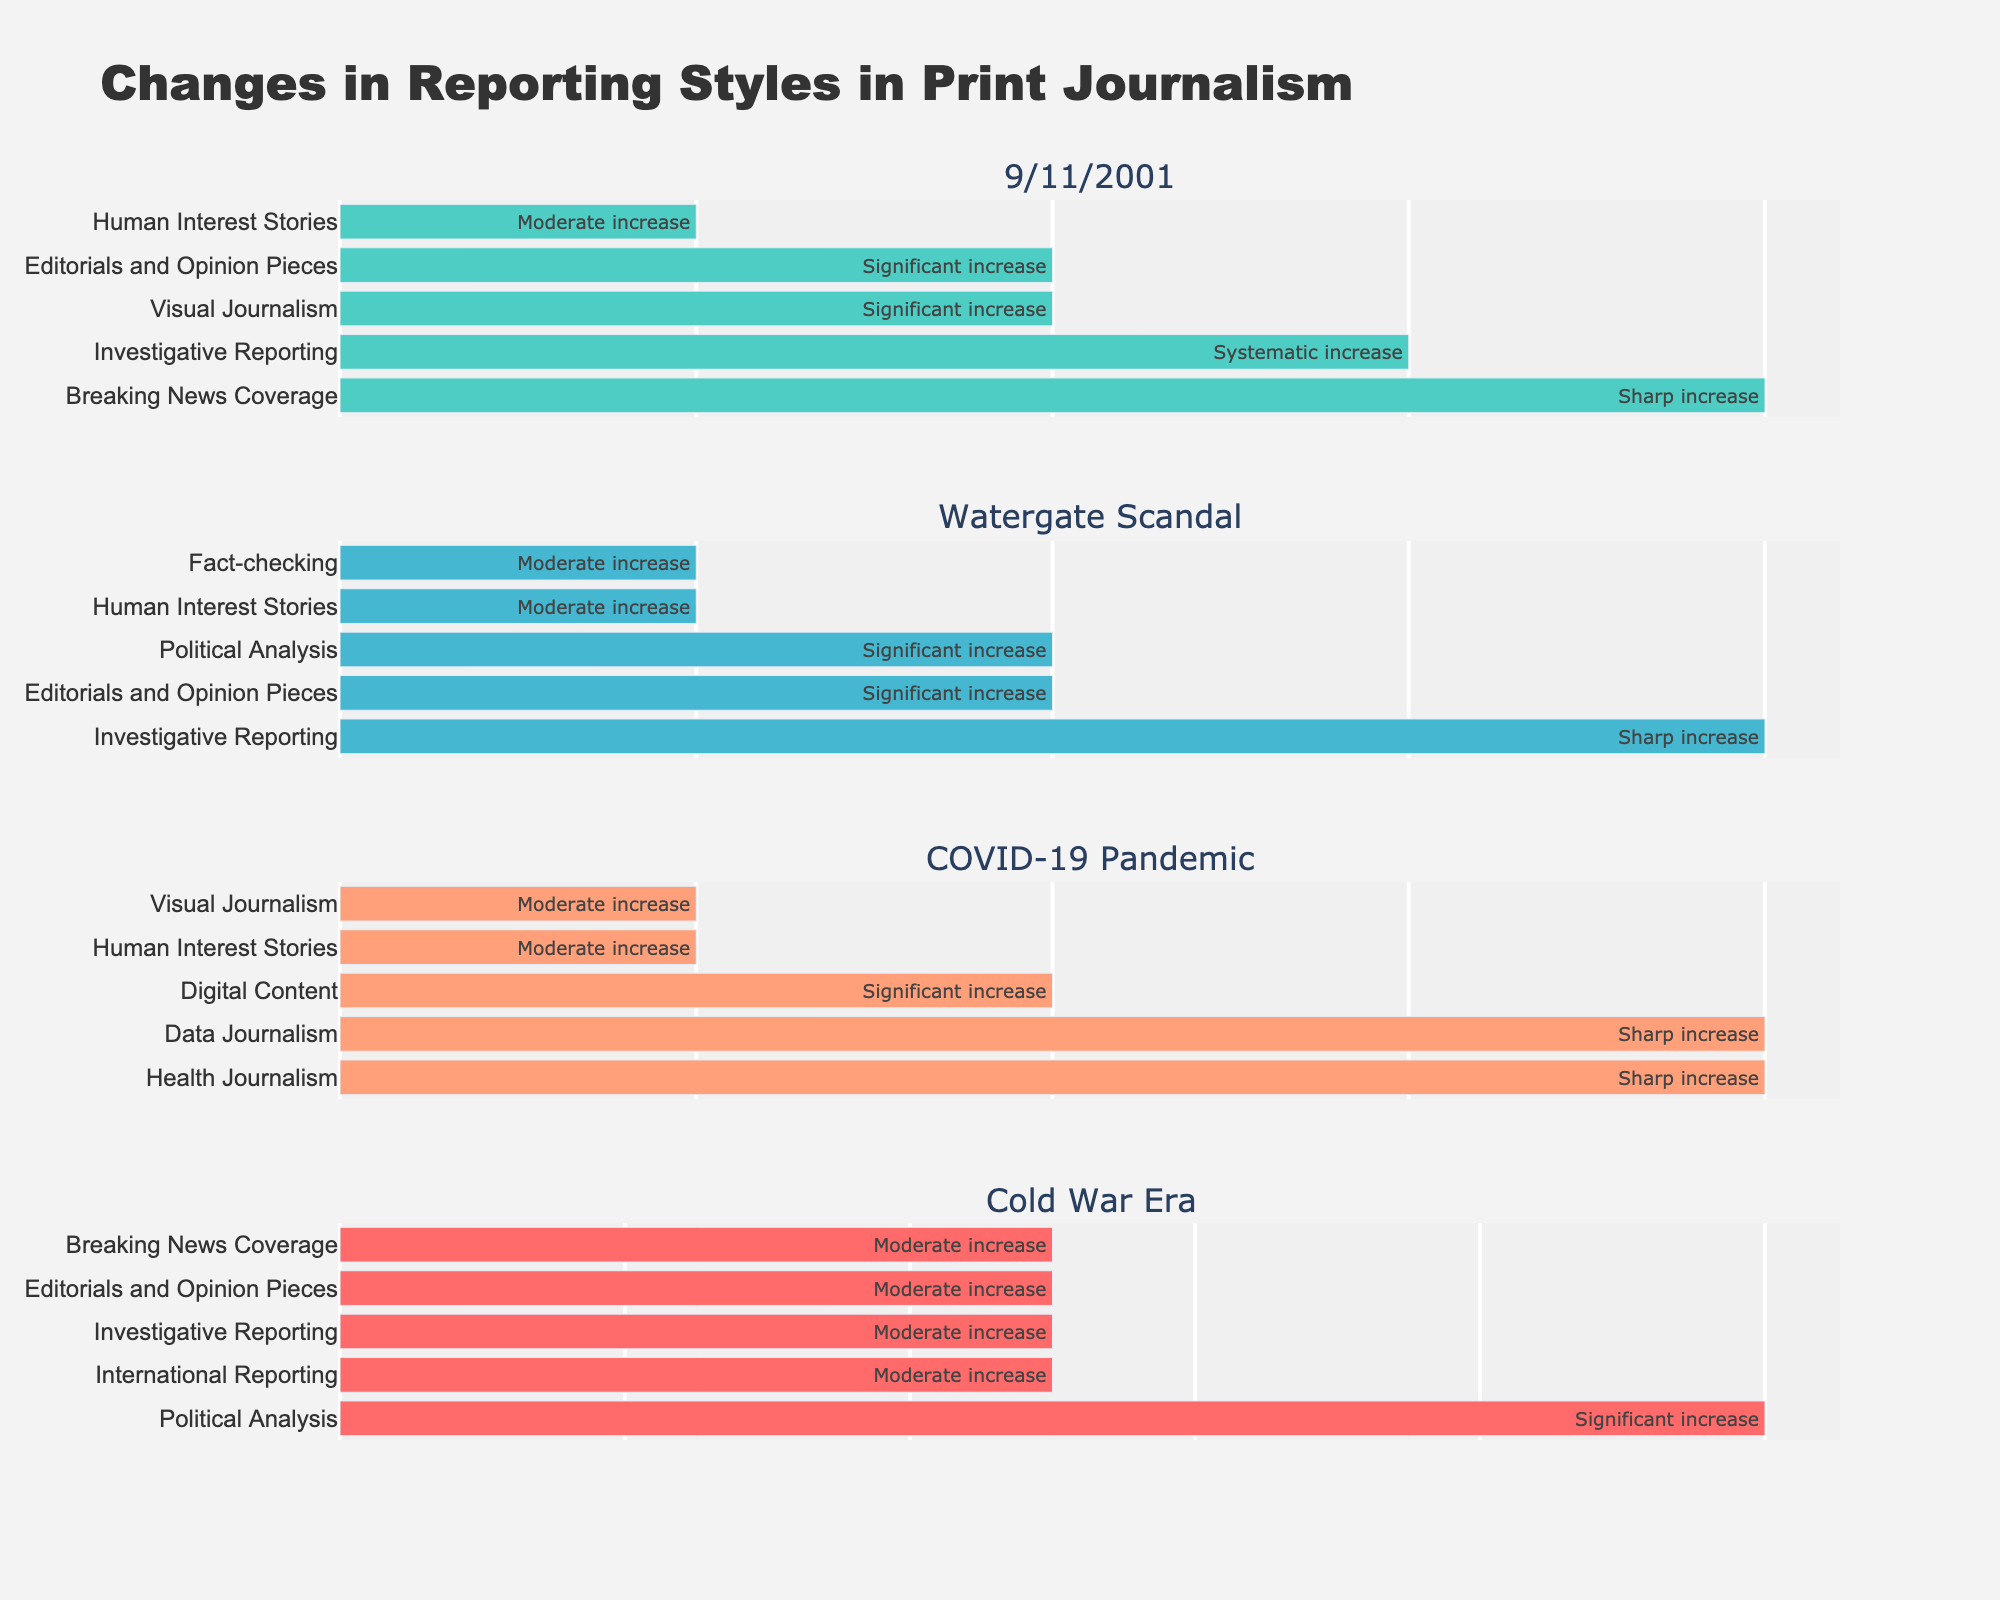What aspect of journalism saw the highest increase after the 9/11 attacks? The bar representing "Breaking News Coverage" shows the highest increase after the 9/11 attacks.
Answer: Breaking News Coverage Which event led to the highest increase in Data Journalism? The figure indicates that a sharp increase in Data Journalism was associated with the COVID-19 Pandemic.
Answer: COVID-19 Pandemic Compare the change in Editorials and Opinion Pieces for 9/11 and the Watergate Scandal. Which event caused a greater increase? Both events show a significant increase in Editorials and Opinion Pieces, making them equal in terms of change.
Answer: Equal Which aspect of journalism had a moderate increase during both the Watergate Scandal and the COVID-19 Pandemic? Human Interest Stories had a moderate increase for both the Watergate Scandal and the COVID-19 Pandemic.
Answer: Human Interest Stories What was the change in Investigative Reporting during the Cold War Era? The bar representing Investigative Reporting during the Cold War Era indicates a moderate increase.
Answer: Moderate increase List the changes in reporting styles seen in Visual Journalism. Visual Journalism shows a significant increase after 9/11 and a moderate increase during the COVID-19 Pandemic.
Answer: Significant increase, Moderate increase Which two aspects showed a sharp increase during their respective events? Breaking News Coverage after 9/11 and Investigative Reporting after the Watergate Scandal both showed a sharp increase.
Answer: Breaking News Coverage, Investigative Reporting Compare Human Interest Stories' change during the COVID-19 Pandemic and the Watergate Scandal. Which one has the larger increase? The figure shows a moderate increase in Human Interest Stories for both the COVID-19 Pandemic and the Watergate Scandal, making them equal.
Answer: Equal How did Editorials and Opinion Pieces change during the Cold War Era? The bar for Editorials and Opinion Pieces during the Cold War Era shows a moderate increase.
Answer: Moderate increase 